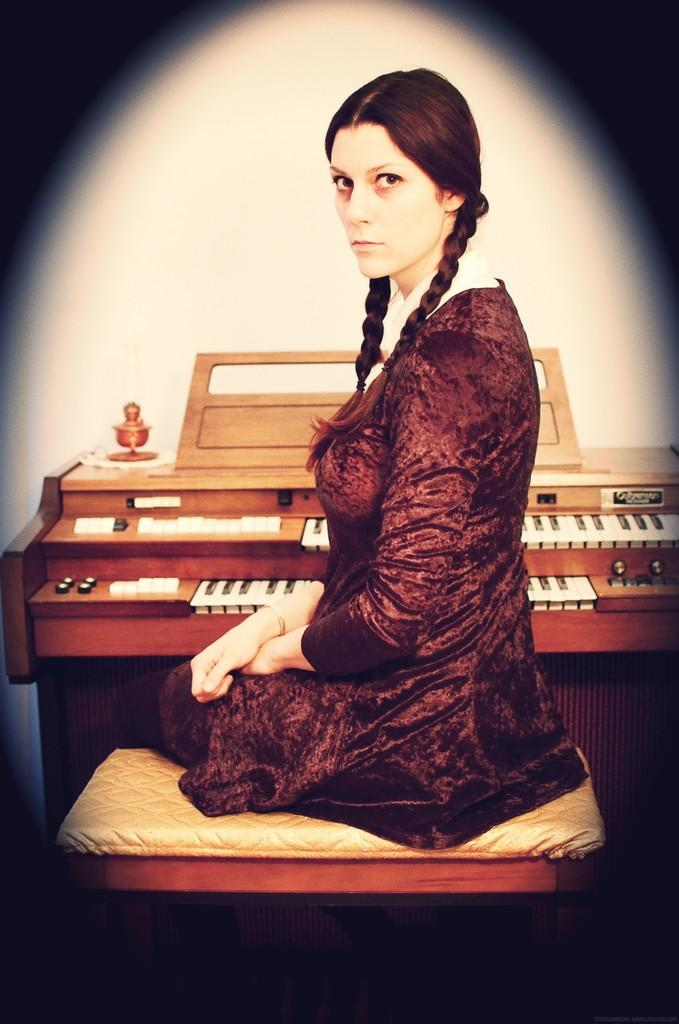Who is present in the image? There is a woman in the image. What is the woman doing in the image? The woman is sitting on a chair. What object can be seen in the image related to music? There is a musical keyboard in the image. What type of secretary is the woman in the image? There is no indication in the image that the woman is a secretary. 